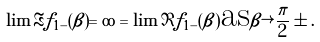Convert formula to latex. <formula><loc_0><loc_0><loc_500><loc_500>\lim \Re f _ { 1 - } ( \beta ) = \infty = \lim \Im f _ { 1 - } ( \beta ) \text {as} \beta \rightarrow \frac { \pi } { 2 } \pm .</formula> 